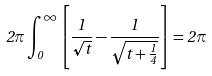Convert formula to latex. <formula><loc_0><loc_0><loc_500><loc_500>2 \pi \int _ { 0 } ^ { \infty } \left [ \frac { 1 } { \sqrt { t } } - \frac { 1 } { \sqrt { t + \frac { 1 } { 4 } } } \right ] = 2 \pi</formula> 